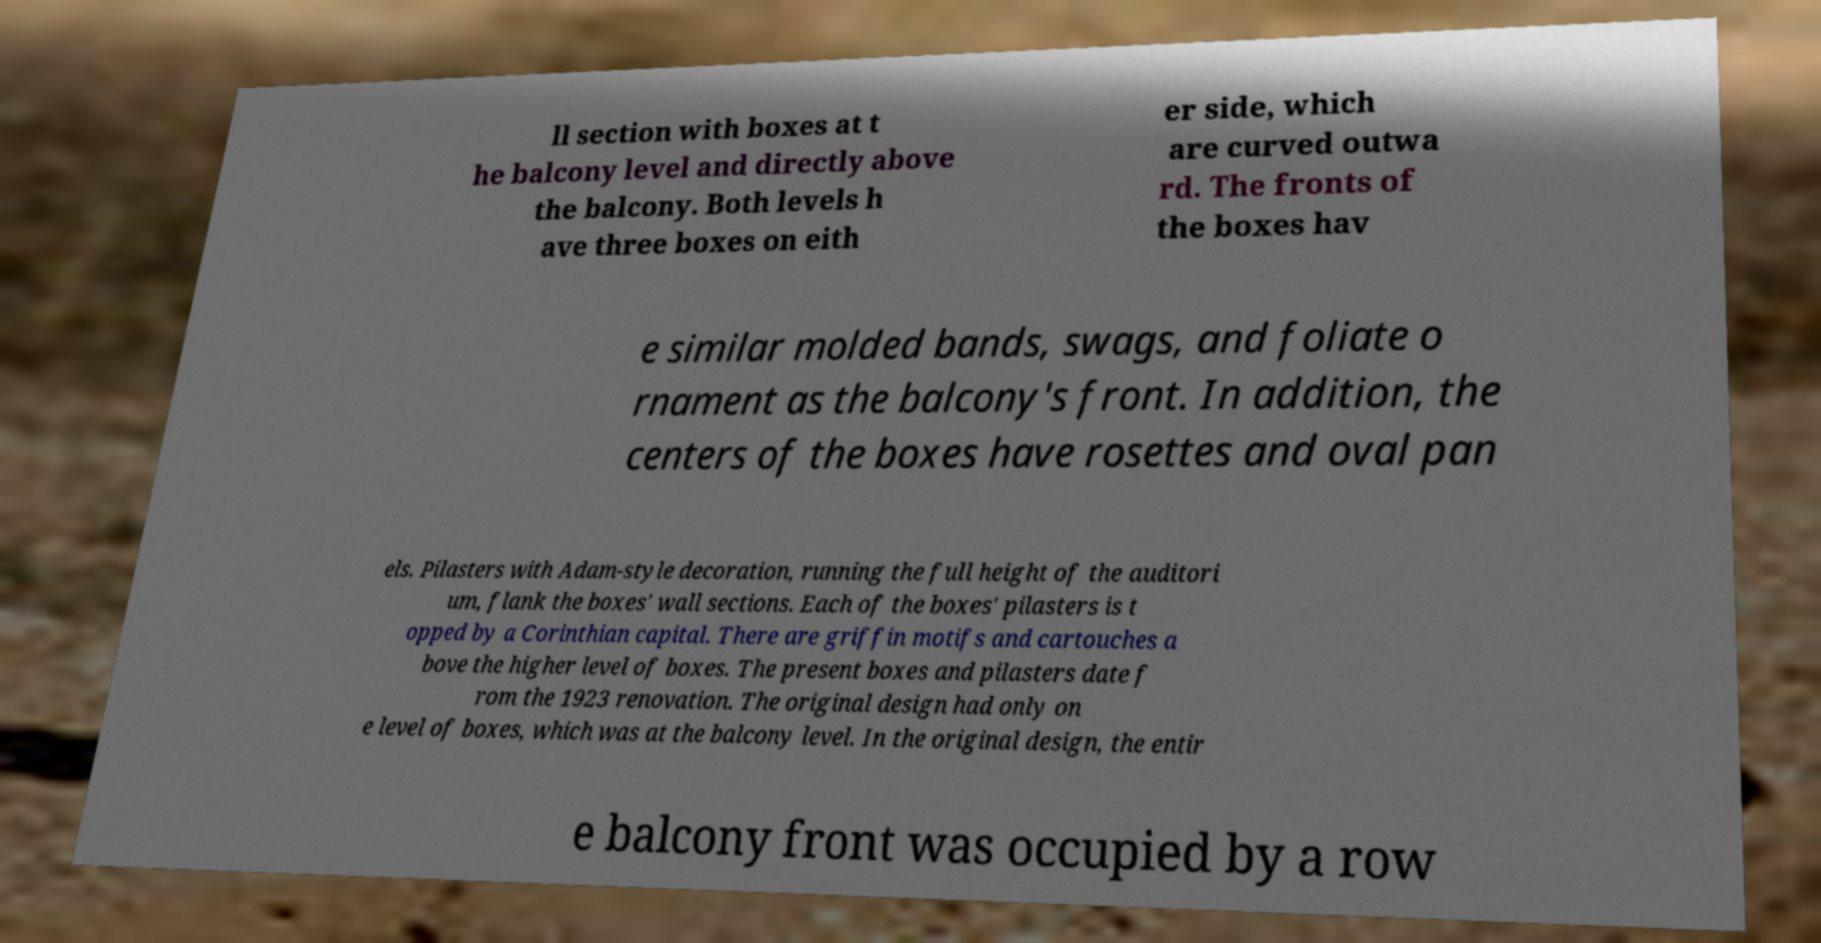Please identify and transcribe the text found in this image. ll section with boxes at t he balcony level and directly above the balcony. Both levels h ave three boxes on eith er side, which are curved outwa rd. The fronts of the boxes hav e similar molded bands, swags, and foliate o rnament as the balcony's front. In addition, the centers of the boxes have rosettes and oval pan els. Pilasters with Adam-style decoration, running the full height of the auditori um, flank the boxes' wall sections. Each of the boxes' pilasters is t opped by a Corinthian capital. There are griffin motifs and cartouches a bove the higher level of boxes. The present boxes and pilasters date f rom the 1923 renovation. The original design had only on e level of boxes, which was at the balcony level. In the original design, the entir e balcony front was occupied by a row 